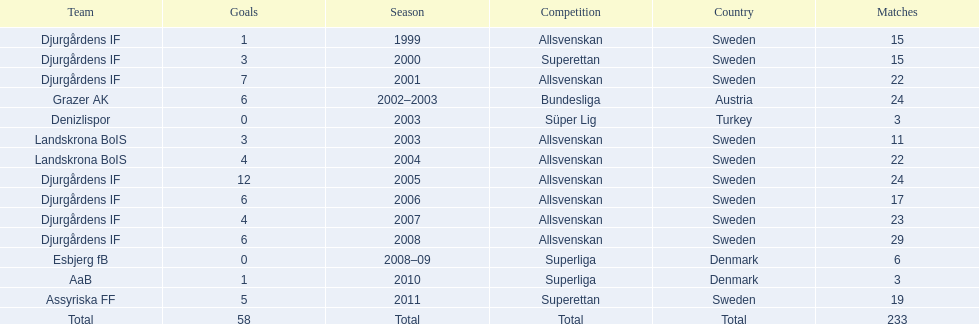How many matches did jones kusi-asare play in in his first season? 15. 